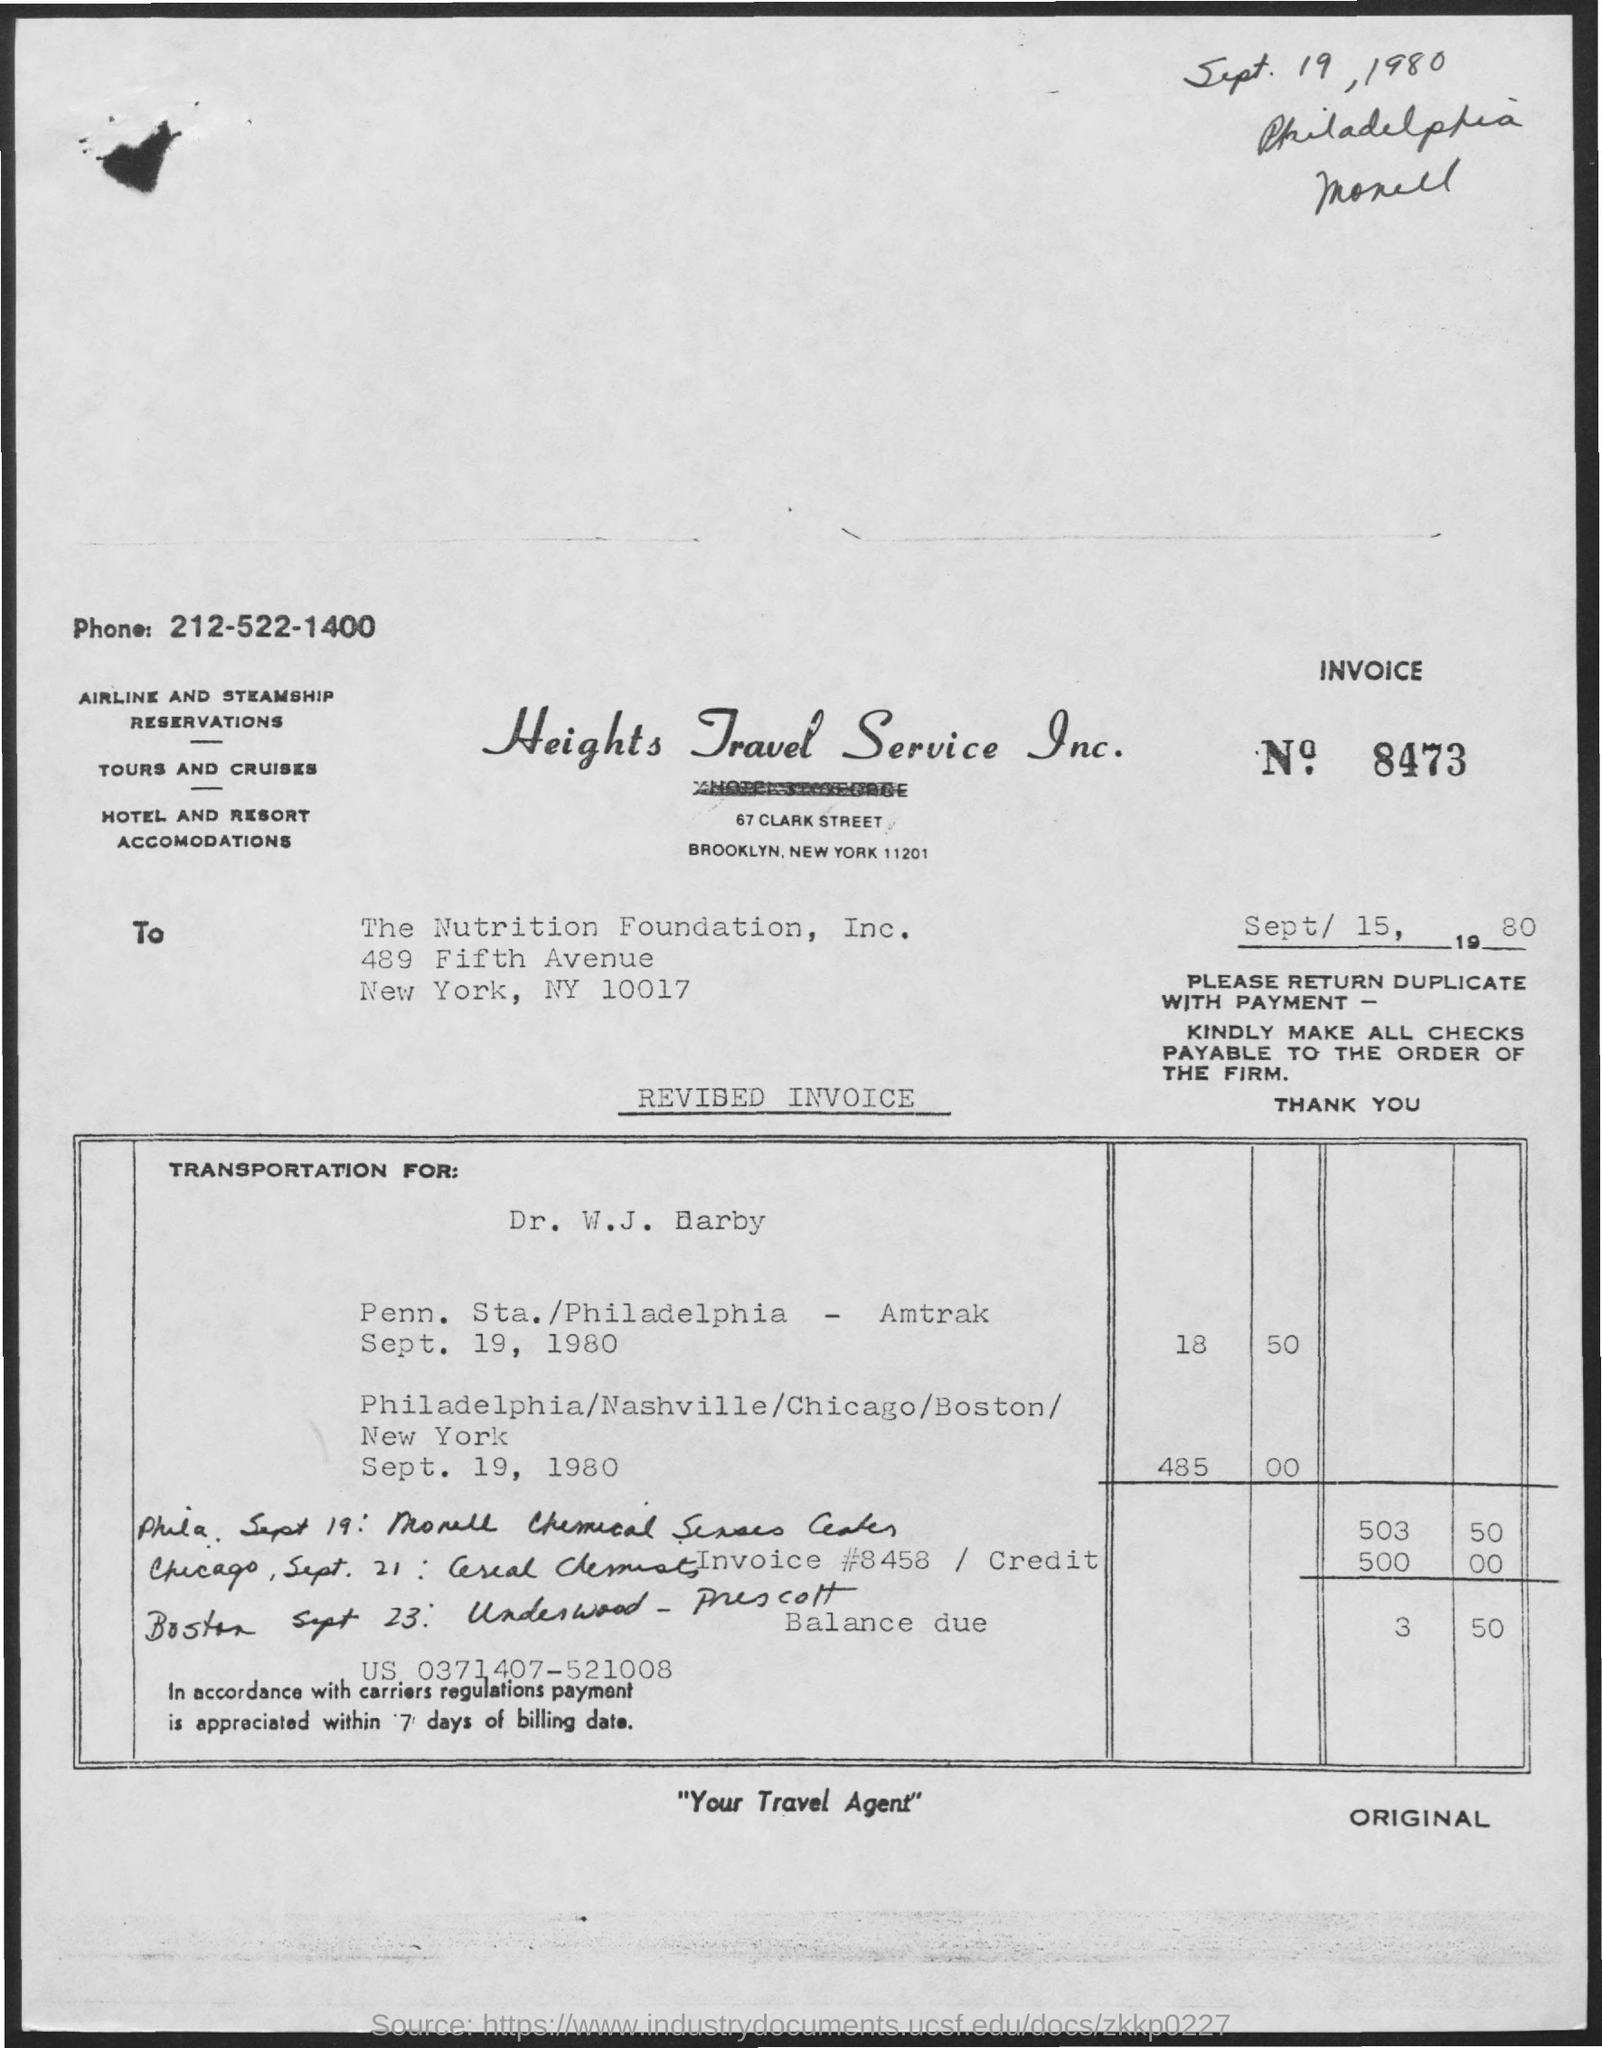What is the phone no. mentioned in the given letter ?
Provide a short and direct response. 212-522-1400. What is the invoice no. mentioned in the given form ?
Make the answer very short. 8473. To whom this letter was written ?
Your answer should be very brief. The Nutrition Foundation, Inc. 